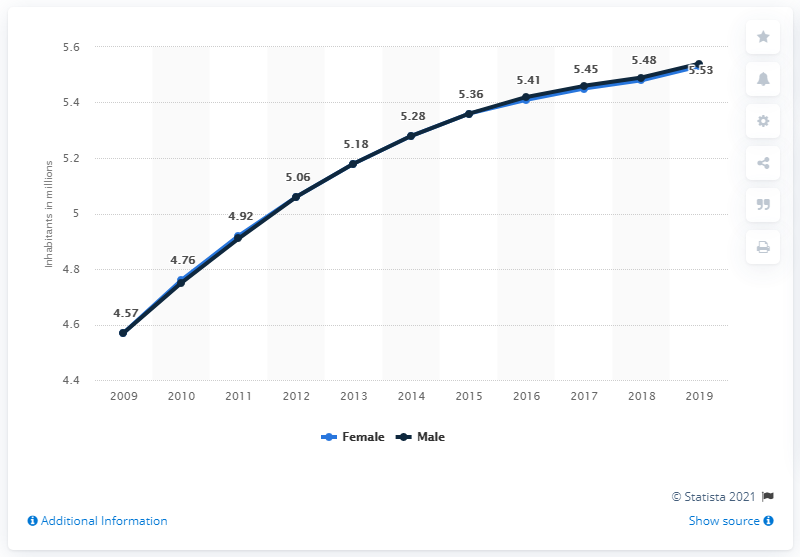Outline some significant characteristics in this image. The first data point in the line graph is 4.57 The average of the last three data points is 5.48. In 2019, the female population of South Sudan was 5.53 million. In 2019, the male population of South Sudan was approximately 5.53 million. 